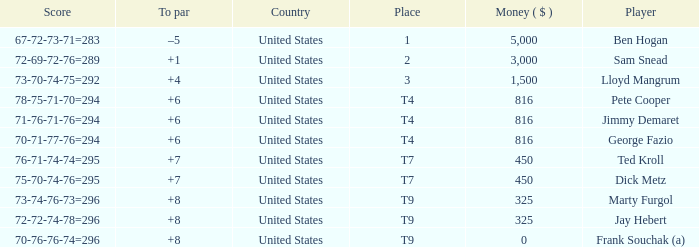Which country is Pete Cooper, who made $816, from? United States. 